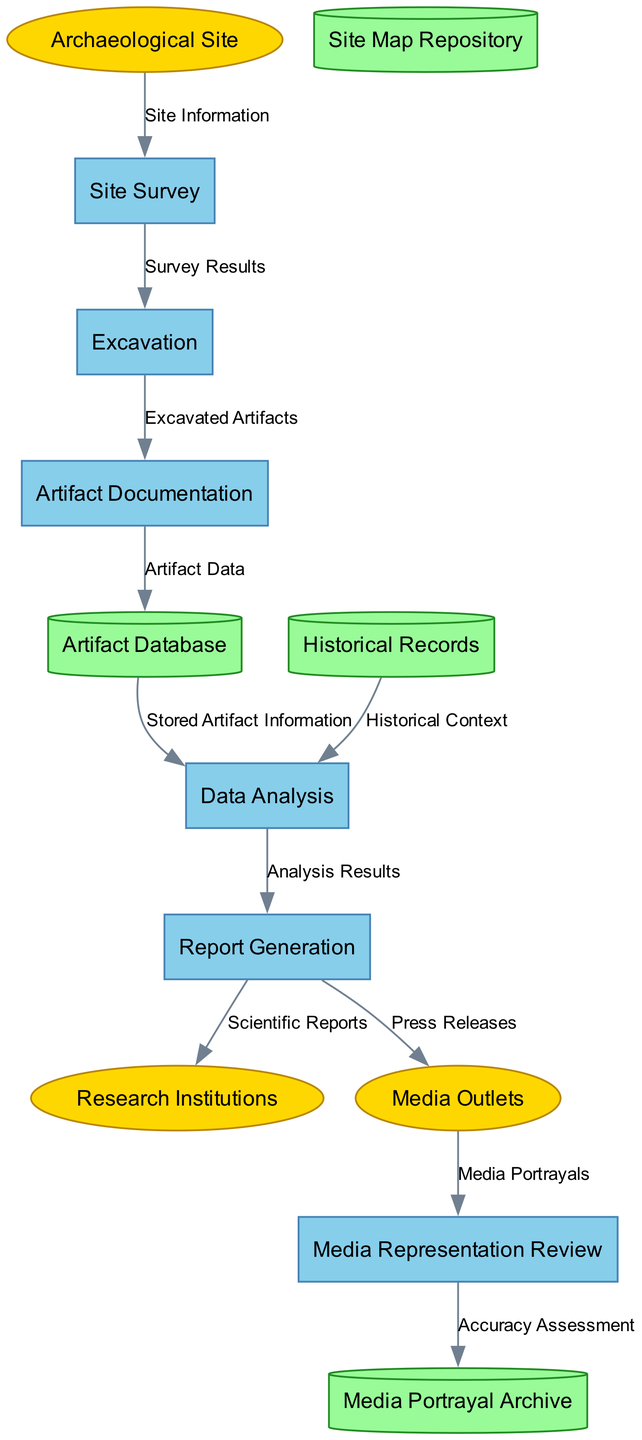What are the external entities present in the diagram? The external entities are listed in the diagram and include "Archaeological Site," "Research Institutions," and "Media Outlets."
Answer: Archaeological Site, Research Institutions, Media Outlets How many processes are illustrated in the diagram? By counting the items in the 'processes' section of the diagram, there are six processes identified: Site Survey, Excavation, Artifact Documentation, Data Analysis, Report Generation, and Media Representation Review.
Answer: 6 What does "Excavation" receive from "Site Survey"? According to the data flow, "Excavation" receives "Survey Results" from "Site Survey." This flow represents the relationship between these two processes.
Answer: Survey Results Which data store is associated with the "Artifact Documentation" process? "Artifact Documentation" is connected to the data store "Artifact Database," where the documented artifact data is stored after documentation.
Answer: Artifact Database What is the flow of "Media Portrayals" after coming from "Media Outlets"? "Media Portrayals" flow into the "Media Representation Review," indicating that after media outlets receive reports, these portrayals are reviewed for accuracy.
Answer: Media Representation Review What type of data does "Data Analysis" process use from the "Historical Records"? "Data Analysis" utilizes "Historical Context" from "Historical Records," combining this historical information with stored artifact data for comprehensive analysis.
Answer: Historical Context What is created after "Data Analysis"? The process immediately following "Data Analysis" is "Report Generation," where the results of analysis are compiled into formal reports.
Answer: Report Generation How many flows go from "Report Generation" to external entities? There are two flows originating from "Report Generation," which go to "Research Institutions" and "Media Outlets," indicating reporting to both entities.
Answer: 2 What is the purpose of the "Media Portrayal Archive"? The "Media Portrayal Archive" serves to store the outcomes of the "Media Representation Review," specifically focusing on the accuracy assessment of media portrayals based on archaeological findings.
Answer: Accuracy Assessment 